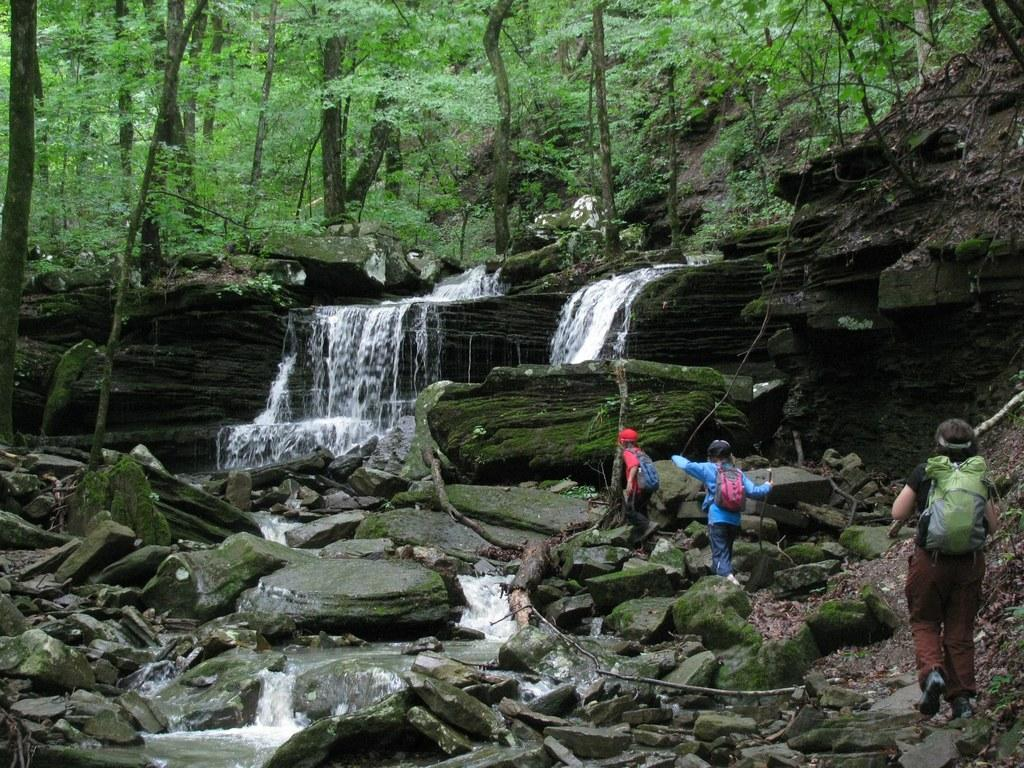What is the main feature in the middle of the image? There is a waterfall in the middle of the image. What type of vegetation is visible at the top of the image? There are trees with green leaves at the top of the image. What are the kids doing on the right side of the image? There are three kids walking on stones on the right side of the image. What type of decision can be seen being made by the waterfall in the image? There is no decision-making process visible in the image; it is a natural waterfall. 